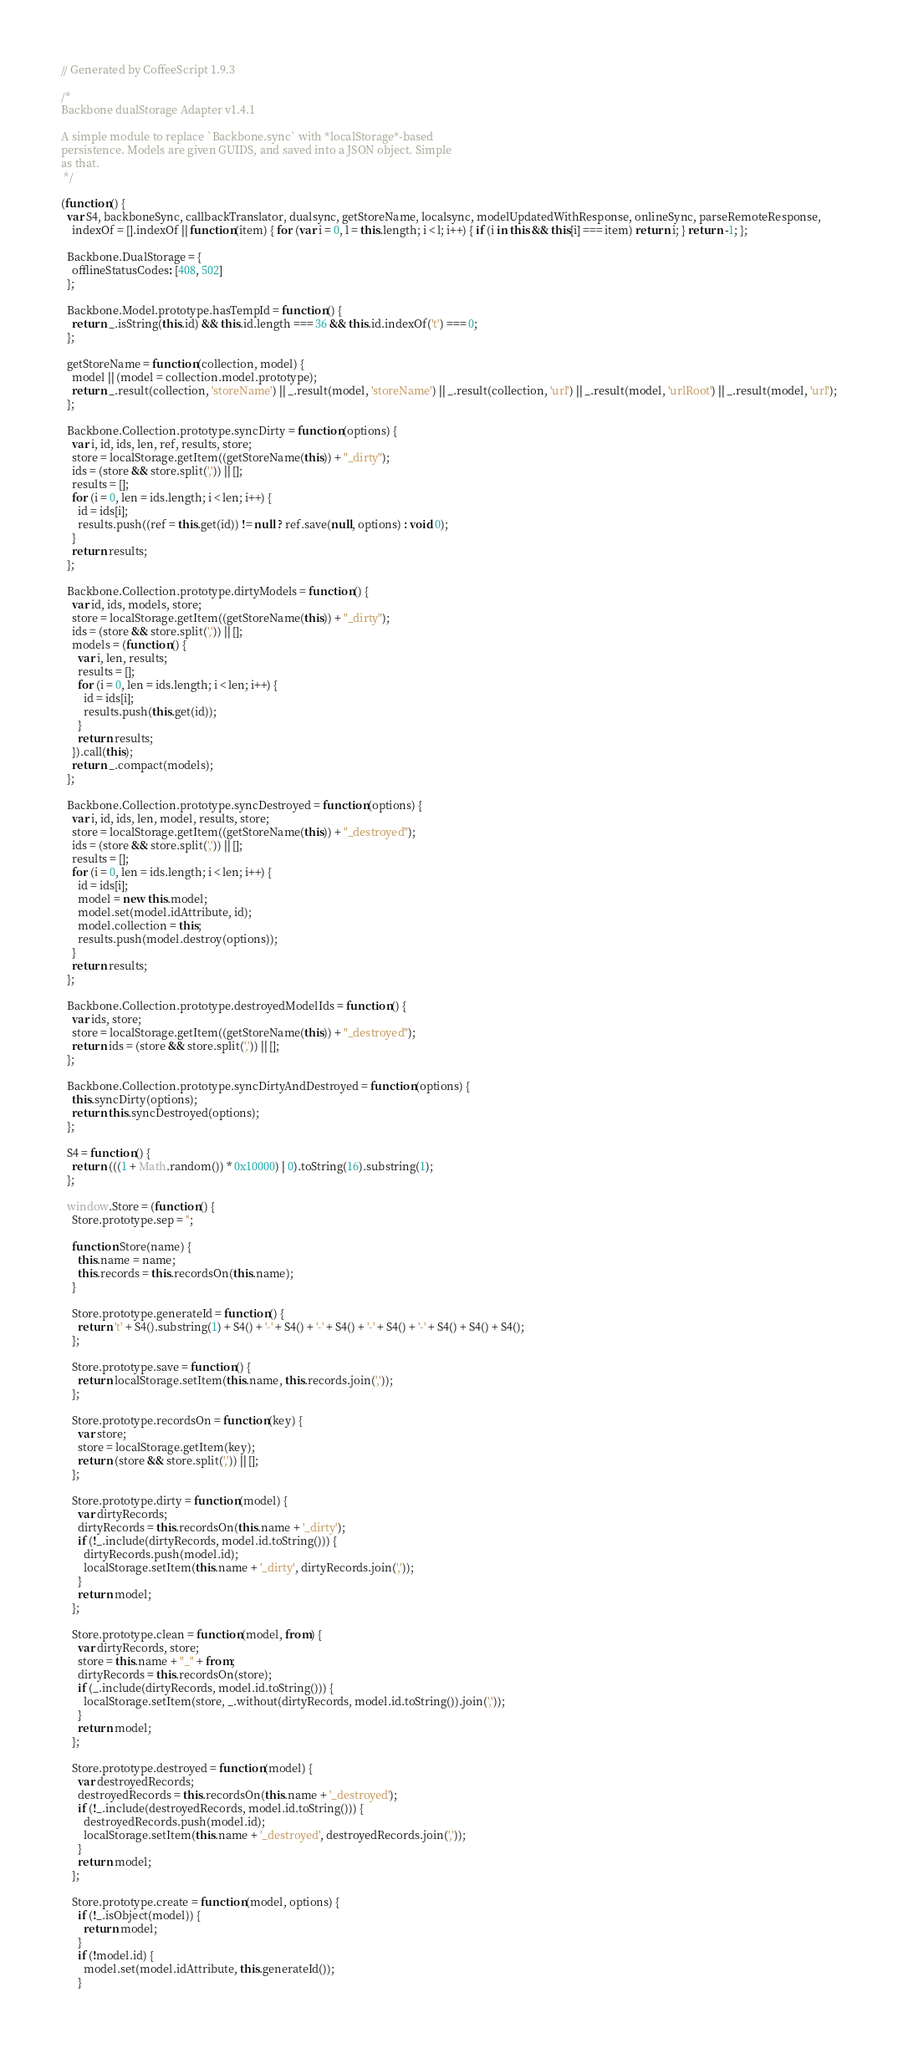Convert code to text. <code><loc_0><loc_0><loc_500><loc_500><_JavaScript_>// Generated by CoffeeScript 1.9.3

/*
Backbone dualStorage Adapter v1.4.1

A simple module to replace `Backbone.sync` with *localStorage*-based
persistence. Models are given GUIDS, and saved into a JSON object. Simple
as that.
 */

(function() {
  var S4, backboneSync, callbackTranslator, dualsync, getStoreName, localsync, modelUpdatedWithResponse, onlineSync, parseRemoteResponse,
    indexOf = [].indexOf || function(item) { for (var i = 0, l = this.length; i < l; i++) { if (i in this && this[i] === item) return i; } return -1; };

  Backbone.DualStorage = {
    offlineStatusCodes: [408, 502]
  };

  Backbone.Model.prototype.hasTempId = function() {
    return _.isString(this.id) && this.id.length === 36 && this.id.indexOf('t') === 0;
  };

  getStoreName = function(collection, model) {
    model || (model = collection.model.prototype);
    return _.result(collection, 'storeName') || _.result(model, 'storeName') || _.result(collection, 'url') || _.result(model, 'urlRoot') || _.result(model, 'url');
  };

  Backbone.Collection.prototype.syncDirty = function(options) {
    var i, id, ids, len, ref, results, store;
    store = localStorage.getItem((getStoreName(this)) + "_dirty");
    ids = (store && store.split(',')) || [];
    results = [];
    for (i = 0, len = ids.length; i < len; i++) {
      id = ids[i];
      results.push((ref = this.get(id)) != null ? ref.save(null, options) : void 0);
    }
    return results;
  };

  Backbone.Collection.prototype.dirtyModels = function() {
    var id, ids, models, store;
    store = localStorage.getItem((getStoreName(this)) + "_dirty");
    ids = (store && store.split(',')) || [];
    models = (function() {
      var i, len, results;
      results = [];
      for (i = 0, len = ids.length; i < len; i++) {
        id = ids[i];
        results.push(this.get(id));
      }
      return results;
    }).call(this);
    return _.compact(models);
  };

  Backbone.Collection.prototype.syncDestroyed = function(options) {
    var i, id, ids, len, model, results, store;
    store = localStorage.getItem((getStoreName(this)) + "_destroyed");
    ids = (store && store.split(',')) || [];
    results = [];
    for (i = 0, len = ids.length; i < len; i++) {
      id = ids[i];
      model = new this.model;
      model.set(model.idAttribute, id);
      model.collection = this;
      results.push(model.destroy(options));
    }
    return results;
  };

  Backbone.Collection.prototype.destroyedModelIds = function() {
    var ids, store;
    store = localStorage.getItem((getStoreName(this)) + "_destroyed");
    return ids = (store && store.split(',')) || [];
  };

  Backbone.Collection.prototype.syncDirtyAndDestroyed = function(options) {
    this.syncDirty(options);
    return this.syncDestroyed(options);
  };

  S4 = function() {
    return (((1 + Math.random()) * 0x10000) | 0).toString(16).substring(1);
  };

  window.Store = (function() {
    Store.prototype.sep = '';

    function Store(name) {
      this.name = name;
      this.records = this.recordsOn(this.name);
    }

    Store.prototype.generateId = function() {
      return 't' + S4().substring(1) + S4() + '-' + S4() + '-' + S4() + '-' + S4() + '-' + S4() + S4() + S4();
    };

    Store.prototype.save = function() {
      return localStorage.setItem(this.name, this.records.join(','));
    };

    Store.prototype.recordsOn = function(key) {
      var store;
      store = localStorage.getItem(key);
      return (store && store.split(',')) || [];
    };

    Store.prototype.dirty = function(model) {
      var dirtyRecords;
      dirtyRecords = this.recordsOn(this.name + '_dirty');
      if (!_.include(dirtyRecords, model.id.toString())) {
        dirtyRecords.push(model.id);
        localStorage.setItem(this.name + '_dirty', dirtyRecords.join(','));
      }
      return model;
    };

    Store.prototype.clean = function(model, from) {
      var dirtyRecords, store;
      store = this.name + "_" + from;
      dirtyRecords = this.recordsOn(store);
      if (_.include(dirtyRecords, model.id.toString())) {
        localStorage.setItem(store, _.without(dirtyRecords, model.id.toString()).join(','));
      }
      return model;
    };

    Store.prototype.destroyed = function(model) {
      var destroyedRecords;
      destroyedRecords = this.recordsOn(this.name + '_destroyed');
      if (!_.include(destroyedRecords, model.id.toString())) {
        destroyedRecords.push(model.id);
        localStorage.setItem(this.name + '_destroyed', destroyedRecords.join(','));
      }
      return model;
    };

    Store.prototype.create = function(model, options) {
      if (!_.isObject(model)) {
        return model;
      }
      if (!model.id) {
        model.set(model.idAttribute, this.generateId());
      }</code> 